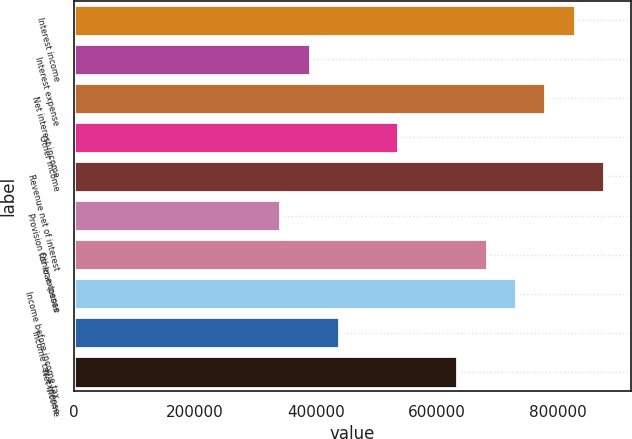Convert chart. <chart><loc_0><loc_0><loc_500><loc_500><bar_chart><fcel>Interest income<fcel>Interest expense<fcel>Net interest income<fcel>Other income<fcel>Revenue net of interest<fcel>Provision for loan losses<fcel>Other expense<fcel>Income before income tax<fcel>Income tax expense<fcel>Net income<nl><fcel>827663<fcel>389489<fcel>778977<fcel>535547<fcel>876349<fcel>340803<fcel>681605<fcel>730291<fcel>438175<fcel>632919<nl></chart> 